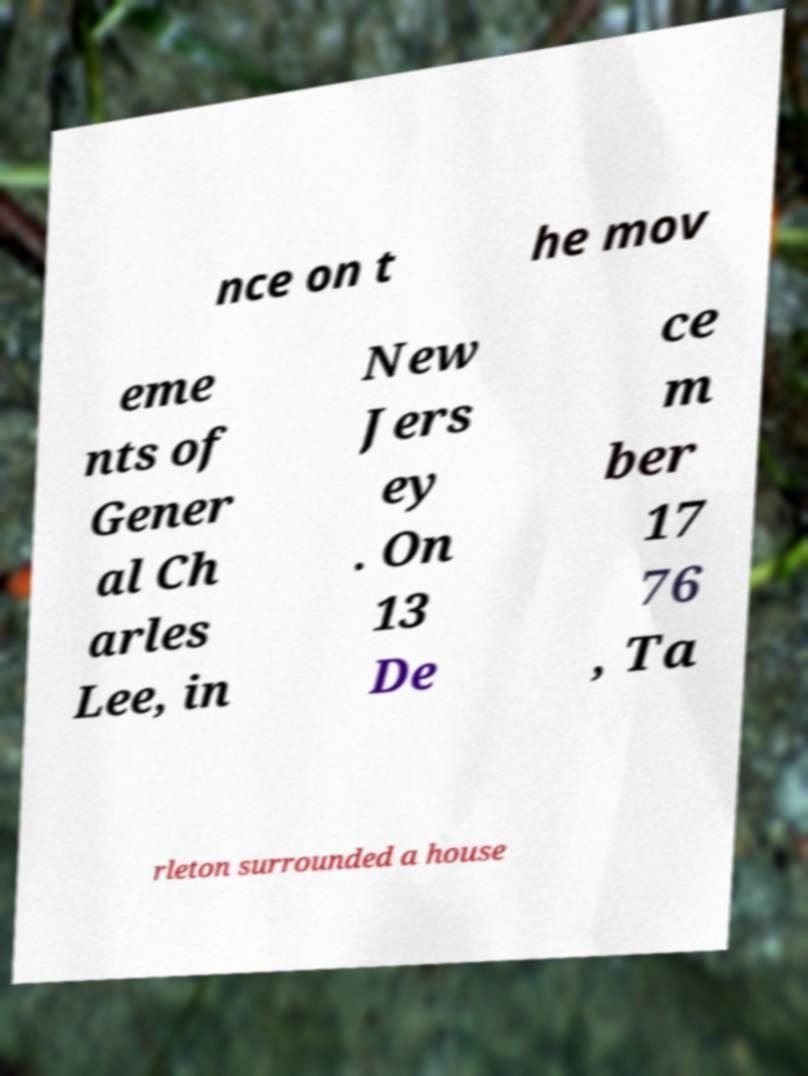Please identify and transcribe the text found in this image. nce on t he mov eme nts of Gener al Ch arles Lee, in New Jers ey . On 13 De ce m ber 17 76 , Ta rleton surrounded a house 